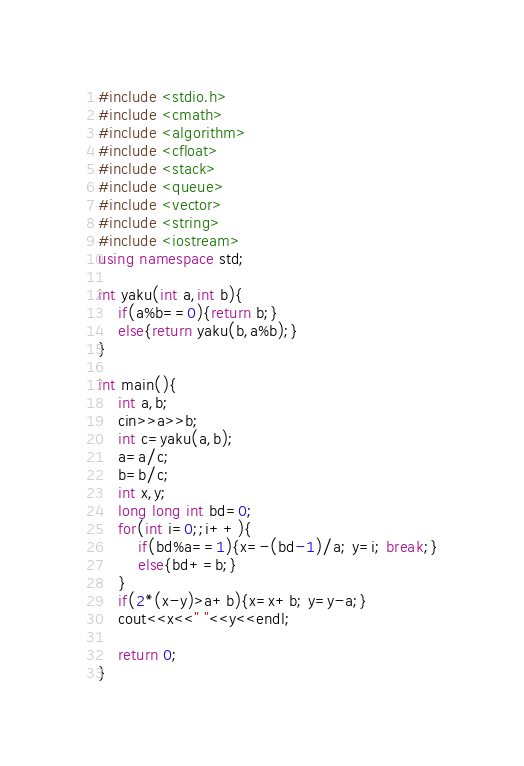<code> <loc_0><loc_0><loc_500><loc_500><_C++_>#include <stdio.h>
#include <cmath>
#include <algorithm>
#include <cfloat>
#include <stack>
#include <queue>
#include <vector>
#include <string>
#include <iostream>
using namespace std;

int yaku(int a,int b){
    if(a%b==0){return b;}
    else{return yaku(b,a%b);}
}

int main(){
    int a,b;
    cin>>a>>b;
    int c=yaku(a,b);
    a=a/c;
    b=b/c;
    int x,y;
    long long int bd=0;
    for(int i=0;;i++){
        if(bd%a==1){x=-(bd-1)/a; y=i; break;}
        else{bd+=b;}
    }
    if(2*(x-y)>a+b){x=x+b; y=y-a;}
    cout<<x<<" "<<y<<endl;
    
    return 0;
}
</code> 